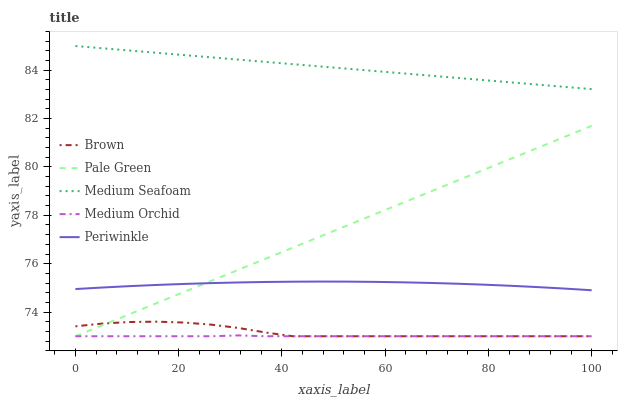Does Medium Orchid have the minimum area under the curve?
Answer yes or no. Yes. Does Medium Seafoam have the maximum area under the curve?
Answer yes or no. Yes. Does Pale Green have the minimum area under the curve?
Answer yes or no. No. Does Pale Green have the maximum area under the curve?
Answer yes or no. No. Is Pale Green the smoothest?
Answer yes or no. Yes. Is Brown the roughest?
Answer yes or no. Yes. Is Medium Orchid the smoothest?
Answer yes or no. No. Is Medium Orchid the roughest?
Answer yes or no. No. Does Brown have the lowest value?
Answer yes or no. Yes. Does Periwinkle have the lowest value?
Answer yes or no. No. Does Medium Seafoam have the highest value?
Answer yes or no. Yes. Does Pale Green have the highest value?
Answer yes or no. No. Is Brown less than Periwinkle?
Answer yes or no. Yes. Is Medium Seafoam greater than Medium Orchid?
Answer yes or no. Yes. Does Periwinkle intersect Pale Green?
Answer yes or no. Yes. Is Periwinkle less than Pale Green?
Answer yes or no. No. Is Periwinkle greater than Pale Green?
Answer yes or no. No. Does Brown intersect Periwinkle?
Answer yes or no. No. 